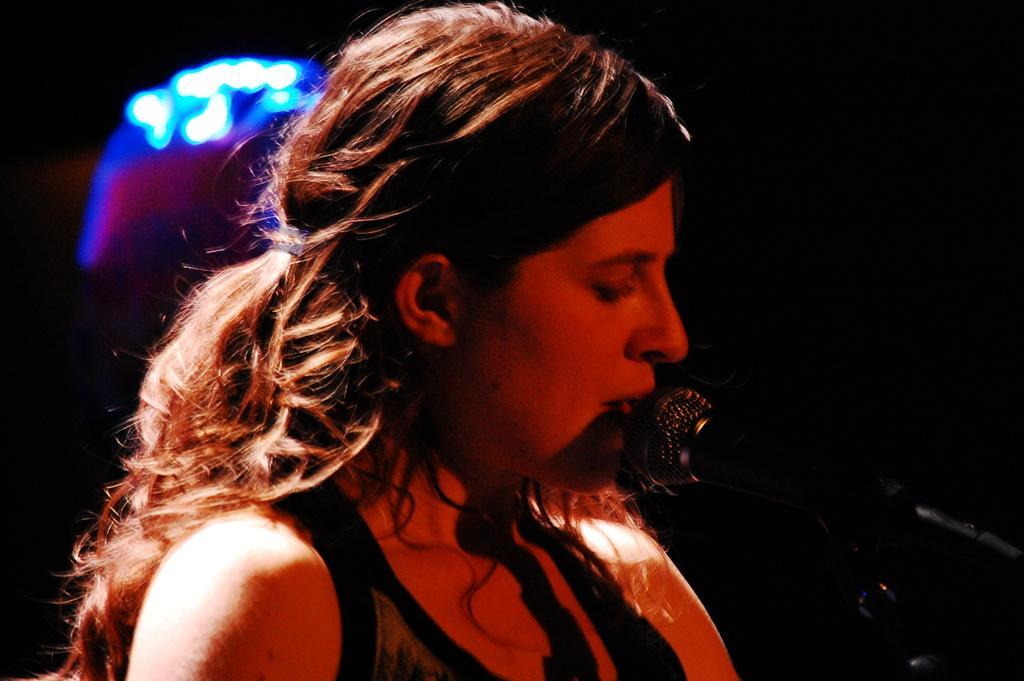How would you summarize this image in a sentence or two? In this image in the foreground there is one woman who is singing, and in front of her there is a mike and there is a dark background and some lights. 